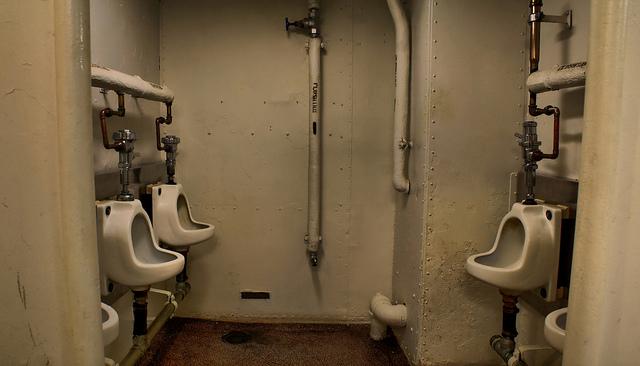Does the floor look nasty and dirty?
Quick response, please. Yes. Is this a men's restroom or a women's restroom?
Quick response, please. Men's. Is there a valve in the image?
Answer briefly. Yes. 